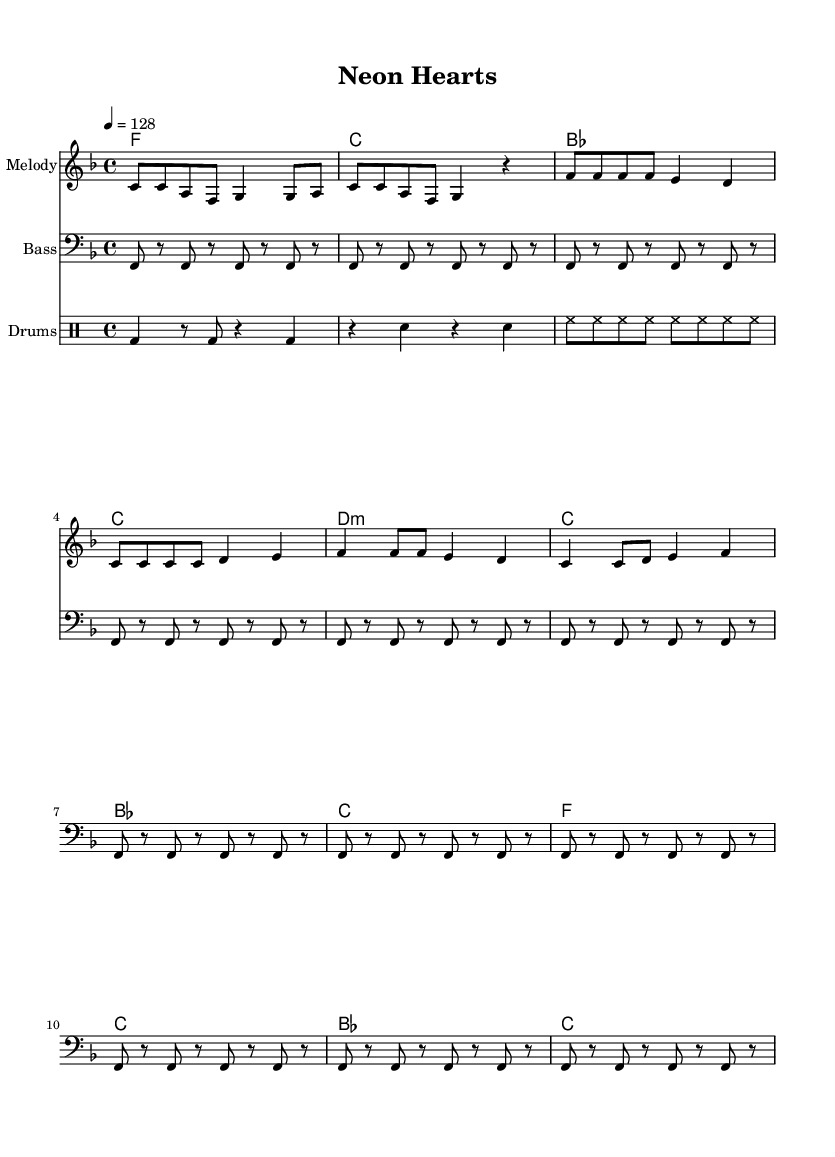What is the key signature of this music? The key signature is F major, which consists of one flat (B flat). It can be identified from the key signature placed at the beginning of the staff.
Answer: F major What is the time signature of this music? The time signature is 4/4, typically represented with a "4" over another "4". This indicates four beats per measure, and it is clearly shown at the beginning of the score.
Answer: 4/4 What is the tempo marking of this piece? The tempo marking of the piece indicates a tempo of 128 beats per minute, which you can find in the tempo markings section of the score.
Answer: 128 Which section begins with "Ne -- on lights are flash -- ing, hearts are ra -- cing fast"? This is from the verse section of the piece. The lyrics are aligned with the melody and specifically designated to that section.
Answer: Verse How many measures does the verse section contain? The verse section contains four measures, which can be counted by observing the bar lines that separate each measure in the score.
Answer: Four What instrument plays the bass part? The bass part is played by a bass instrument, as indicated by the staff designation which specifies "Bass" for that section.
Answer: Bass How does the harmony change in the pre-chorus compared to the verse? In the pre-chorus, the harmony transitions from F major in the verse to D minor, with a clear chord change reflecting this. This is determined by comparing the chord symbols under each section.
Answer: D minor 